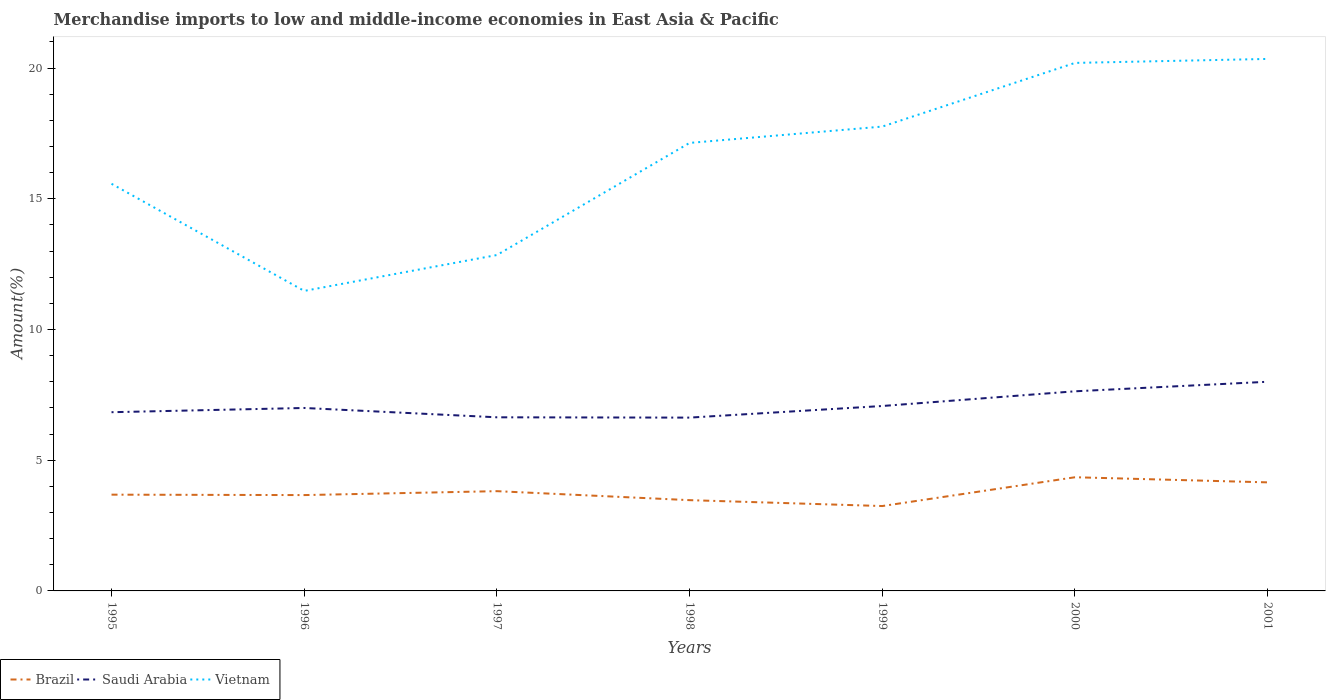How many different coloured lines are there?
Provide a short and direct response. 3. Does the line corresponding to Saudi Arabia intersect with the line corresponding to Vietnam?
Your answer should be compact. No. Across all years, what is the maximum percentage of amount earned from merchandise imports in Brazil?
Provide a succinct answer. 3.25. In which year was the percentage of amount earned from merchandise imports in Vietnam maximum?
Your answer should be very brief. 1996. What is the total percentage of amount earned from merchandise imports in Brazil in the graph?
Your answer should be compact. 0.44. What is the difference between the highest and the second highest percentage of amount earned from merchandise imports in Saudi Arabia?
Give a very brief answer. 1.37. What is the difference between the highest and the lowest percentage of amount earned from merchandise imports in Vietnam?
Provide a short and direct response. 4. How many years are there in the graph?
Keep it short and to the point. 7. What is the difference between two consecutive major ticks on the Y-axis?
Ensure brevity in your answer.  5. Does the graph contain any zero values?
Your answer should be compact. No. Does the graph contain grids?
Provide a succinct answer. No. Where does the legend appear in the graph?
Offer a terse response. Bottom left. What is the title of the graph?
Your answer should be compact. Merchandise imports to low and middle-income economies in East Asia & Pacific. Does "Tuvalu" appear as one of the legend labels in the graph?
Offer a very short reply. No. What is the label or title of the X-axis?
Provide a succinct answer. Years. What is the label or title of the Y-axis?
Offer a very short reply. Amount(%). What is the Amount(%) of Brazil in 1995?
Your answer should be compact. 3.68. What is the Amount(%) in Saudi Arabia in 1995?
Ensure brevity in your answer.  6.84. What is the Amount(%) of Vietnam in 1995?
Provide a succinct answer. 15.57. What is the Amount(%) in Brazil in 1996?
Ensure brevity in your answer.  3.67. What is the Amount(%) in Saudi Arabia in 1996?
Provide a succinct answer. 7. What is the Amount(%) in Vietnam in 1996?
Keep it short and to the point. 11.48. What is the Amount(%) of Brazil in 1997?
Make the answer very short. 3.82. What is the Amount(%) in Saudi Arabia in 1997?
Your response must be concise. 6.64. What is the Amount(%) in Vietnam in 1997?
Your answer should be compact. 12.85. What is the Amount(%) of Brazil in 1998?
Offer a terse response. 3.47. What is the Amount(%) in Saudi Arabia in 1998?
Offer a terse response. 6.63. What is the Amount(%) of Vietnam in 1998?
Keep it short and to the point. 17.14. What is the Amount(%) of Brazil in 1999?
Your answer should be compact. 3.25. What is the Amount(%) of Saudi Arabia in 1999?
Provide a short and direct response. 7.07. What is the Amount(%) in Vietnam in 1999?
Give a very brief answer. 17.76. What is the Amount(%) of Brazil in 2000?
Your answer should be compact. 4.35. What is the Amount(%) of Saudi Arabia in 2000?
Offer a terse response. 7.64. What is the Amount(%) of Vietnam in 2000?
Offer a very short reply. 20.2. What is the Amount(%) in Brazil in 2001?
Keep it short and to the point. 4.15. What is the Amount(%) in Saudi Arabia in 2001?
Your answer should be very brief. 8. What is the Amount(%) of Vietnam in 2001?
Provide a short and direct response. 20.35. Across all years, what is the maximum Amount(%) in Brazil?
Your answer should be very brief. 4.35. Across all years, what is the maximum Amount(%) of Saudi Arabia?
Offer a very short reply. 8. Across all years, what is the maximum Amount(%) of Vietnam?
Your answer should be very brief. 20.35. Across all years, what is the minimum Amount(%) of Brazil?
Provide a short and direct response. 3.25. Across all years, what is the minimum Amount(%) of Saudi Arabia?
Your response must be concise. 6.63. Across all years, what is the minimum Amount(%) in Vietnam?
Offer a very short reply. 11.48. What is the total Amount(%) in Brazil in the graph?
Your answer should be compact. 26.38. What is the total Amount(%) of Saudi Arabia in the graph?
Your answer should be very brief. 49.81. What is the total Amount(%) in Vietnam in the graph?
Keep it short and to the point. 115.34. What is the difference between the Amount(%) of Brazil in 1995 and that in 1996?
Your answer should be compact. 0.02. What is the difference between the Amount(%) in Saudi Arabia in 1995 and that in 1996?
Offer a very short reply. -0.16. What is the difference between the Amount(%) in Vietnam in 1995 and that in 1996?
Ensure brevity in your answer.  4.1. What is the difference between the Amount(%) of Brazil in 1995 and that in 1997?
Your answer should be compact. -0.13. What is the difference between the Amount(%) in Saudi Arabia in 1995 and that in 1997?
Your answer should be compact. 0.19. What is the difference between the Amount(%) of Vietnam in 1995 and that in 1997?
Offer a very short reply. 2.72. What is the difference between the Amount(%) of Brazil in 1995 and that in 1998?
Your response must be concise. 0.21. What is the difference between the Amount(%) in Saudi Arabia in 1995 and that in 1998?
Provide a succinct answer. 0.21. What is the difference between the Amount(%) of Vietnam in 1995 and that in 1998?
Keep it short and to the point. -1.56. What is the difference between the Amount(%) of Brazil in 1995 and that in 1999?
Your answer should be compact. 0.44. What is the difference between the Amount(%) of Saudi Arabia in 1995 and that in 1999?
Provide a short and direct response. -0.24. What is the difference between the Amount(%) in Vietnam in 1995 and that in 1999?
Your answer should be compact. -2.19. What is the difference between the Amount(%) in Brazil in 1995 and that in 2000?
Make the answer very short. -0.67. What is the difference between the Amount(%) of Saudi Arabia in 1995 and that in 2000?
Your answer should be compact. -0.8. What is the difference between the Amount(%) of Vietnam in 1995 and that in 2000?
Keep it short and to the point. -4.62. What is the difference between the Amount(%) of Brazil in 1995 and that in 2001?
Your answer should be very brief. -0.47. What is the difference between the Amount(%) in Saudi Arabia in 1995 and that in 2001?
Offer a terse response. -1.16. What is the difference between the Amount(%) in Vietnam in 1995 and that in 2001?
Your answer should be very brief. -4.78. What is the difference between the Amount(%) of Brazil in 1996 and that in 1997?
Your response must be concise. -0.15. What is the difference between the Amount(%) in Saudi Arabia in 1996 and that in 1997?
Provide a short and direct response. 0.36. What is the difference between the Amount(%) in Vietnam in 1996 and that in 1997?
Ensure brevity in your answer.  -1.37. What is the difference between the Amount(%) of Brazil in 1996 and that in 1998?
Ensure brevity in your answer.  0.19. What is the difference between the Amount(%) in Saudi Arabia in 1996 and that in 1998?
Offer a very short reply. 0.37. What is the difference between the Amount(%) of Vietnam in 1996 and that in 1998?
Make the answer very short. -5.66. What is the difference between the Amount(%) of Brazil in 1996 and that in 1999?
Offer a terse response. 0.42. What is the difference between the Amount(%) in Saudi Arabia in 1996 and that in 1999?
Offer a very short reply. -0.08. What is the difference between the Amount(%) of Vietnam in 1996 and that in 1999?
Your response must be concise. -6.29. What is the difference between the Amount(%) in Brazil in 1996 and that in 2000?
Make the answer very short. -0.68. What is the difference between the Amount(%) in Saudi Arabia in 1996 and that in 2000?
Ensure brevity in your answer.  -0.64. What is the difference between the Amount(%) in Vietnam in 1996 and that in 2000?
Your answer should be compact. -8.72. What is the difference between the Amount(%) in Brazil in 1996 and that in 2001?
Offer a terse response. -0.49. What is the difference between the Amount(%) in Saudi Arabia in 1996 and that in 2001?
Make the answer very short. -1. What is the difference between the Amount(%) of Vietnam in 1996 and that in 2001?
Offer a very short reply. -8.87. What is the difference between the Amount(%) of Brazil in 1997 and that in 1998?
Your response must be concise. 0.34. What is the difference between the Amount(%) in Saudi Arabia in 1997 and that in 1998?
Provide a short and direct response. 0.01. What is the difference between the Amount(%) in Vietnam in 1997 and that in 1998?
Give a very brief answer. -4.29. What is the difference between the Amount(%) of Brazil in 1997 and that in 1999?
Keep it short and to the point. 0.57. What is the difference between the Amount(%) in Saudi Arabia in 1997 and that in 1999?
Offer a very short reply. -0.43. What is the difference between the Amount(%) in Vietnam in 1997 and that in 1999?
Your answer should be very brief. -4.91. What is the difference between the Amount(%) in Brazil in 1997 and that in 2000?
Offer a very short reply. -0.53. What is the difference between the Amount(%) of Saudi Arabia in 1997 and that in 2000?
Provide a succinct answer. -0.99. What is the difference between the Amount(%) of Vietnam in 1997 and that in 2000?
Make the answer very short. -7.35. What is the difference between the Amount(%) in Brazil in 1997 and that in 2001?
Ensure brevity in your answer.  -0.34. What is the difference between the Amount(%) of Saudi Arabia in 1997 and that in 2001?
Make the answer very short. -1.36. What is the difference between the Amount(%) of Vietnam in 1997 and that in 2001?
Offer a very short reply. -7.5. What is the difference between the Amount(%) of Brazil in 1998 and that in 1999?
Your response must be concise. 0.23. What is the difference between the Amount(%) of Saudi Arabia in 1998 and that in 1999?
Your answer should be compact. -0.44. What is the difference between the Amount(%) of Vietnam in 1998 and that in 1999?
Make the answer very short. -0.62. What is the difference between the Amount(%) of Brazil in 1998 and that in 2000?
Make the answer very short. -0.88. What is the difference between the Amount(%) of Saudi Arabia in 1998 and that in 2000?
Provide a succinct answer. -1.01. What is the difference between the Amount(%) of Vietnam in 1998 and that in 2000?
Ensure brevity in your answer.  -3.06. What is the difference between the Amount(%) of Brazil in 1998 and that in 2001?
Make the answer very short. -0.68. What is the difference between the Amount(%) of Saudi Arabia in 1998 and that in 2001?
Offer a terse response. -1.37. What is the difference between the Amount(%) in Vietnam in 1998 and that in 2001?
Your answer should be compact. -3.21. What is the difference between the Amount(%) of Brazil in 1999 and that in 2000?
Ensure brevity in your answer.  -1.1. What is the difference between the Amount(%) of Saudi Arabia in 1999 and that in 2000?
Your answer should be compact. -0.56. What is the difference between the Amount(%) in Vietnam in 1999 and that in 2000?
Your response must be concise. -2.44. What is the difference between the Amount(%) of Brazil in 1999 and that in 2001?
Keep it short and to the point. -0.91. What is the difference between the Amount(%) of Saudi Arabia in 1999 and that in 2001?
Your response must be concise. -0.93. What is the difference between the Amount(%) in Vietnam in 1999 and that in 2001?
Offer a terse response. -2.59. What is the difference between the Amount(%) in Brazil in 2000 and that in 2001?
Keep it short and to the point. 0.2. What is the difference between the Amount(%) in Saudi Arabia in 2000 and that in 2001?
Keep it short and to the point. -0.36. What is the difference between the Amount(%) in Vietnam in 2000 and that in 2001?
Ensure brevity in your answer.  -0.15. What is the difference between the Amount(%) of Brazil in 1995 and the Amount(%) of Saudi Arabia in 1996?
Your answer should be very brief. -3.32. What is the difference between the Amount(%) of Brazil in 1995 and the Amount(%) of Vietnam in 1996?
Provide a short and direct response. -7.79. What is the difference between the Amount(%) of Saudi Arabia in 1995 and the Amount(%) of Vietnam in 1996?
Make the answer very short. -4.64. What is the difference between the Amount(%) of Brazil in 1995 and the Amount(%) of Saudi Arabia in 1997?
Make the answer very short. -2.96. What is the difference between the Amount(%) in Brazil in 1995 and the Amount(%) in Vietnam in 1997?
Keep it short and to the point. -9.17. What is the difference between the Amount(%) in Saudi Arabia in 1995 and the Amount(%) in Vietnam in 1997?
Offer a terse response. -6.01. What is the difference between the Amount(%) in Brazil in 1995 and the Amount(%) in Saudi Arabia in 1998?
Keep it short and to the point. -2.95. What is the difference between the Amount(%) of Brazil in 1995 and the Amount(%) of Vietnam in 1998?
Make the answer very short. -13.45. What is the difference between the Amount(%) of Saudi Arabia in 1995 and the Amount(%) of Vietnam in 1998?
Your answer should be very brief. -10.3. What is the difference between the Amount(%) of Brazil in 1995 and the Amount(%) of Saudi Arabia in 1999?
Ensure brevity in your answer.  -3.39. What is the difference between the Amount(%) of Brazil in 1995 and the Amount(%) of Vietnam in 1999?
Make the answer very short. -14.08. What is the difference between the Amount(%) of Saudi Arabia in 1995 and the Amount(%) of Vietnam in 1999?
Keep it short and to the point. -10.93. What is the difference between the Amount(%) in Brazil in 1995 and the Amount(%) in Saudi Arabia in 2000?
Offer a terse response. -3.95. What is the difference between the Amount(%) in Brazil in 1995 and the Amount(%) in Vietnam in 2000?
Your answer should be compact. -16.51. What is the difference between the Amount(%) in Saudi Arabia in 1995 and the Amount(%) in Vietnam in 2000?
Your response must be concise. -13.36. What is the difference between the Amount(%) of Brazil in 1995 and the Amount(%) of Saudi Arabia in 2001?
Offer a terse response. -4.32. What is the difference between the Amount(%) of Brazil in 1995 and the Amount(%) of Vietnam in 2001?
Offer a terse response. -16.67. What is the difference between the Amount(%) in Saudi Arabia in 1995 and the Amount(%) in Vietnam in 2001?
Offer a terse response. -13.51. What is the difference between the Amount(%) of Brazil in 1996 and the Amount(%) of Saudi Arabia in 1997?
Your response must be concise. -2.98. What is the difference between the Amount(%) of Brazil in 1996 and the Amount(%) of Vietnam in 1997?
Your answer should be very brief. -9.18. What is the difference between the Amount(%) in Saudi Arabia in 1996 and the Amount(%) in Vietnam in 1997?
Your response must be concise. -5.85. What is the difference between the Amount(%) of Brazil in 1996 and the Amount(%) of Saudi Arabia in 1998?
Offer a very short reply. -2.96. What is the difference between the Amount(%) of Brazil in 1996 and the Amount(%) of Vietnam in 1998?
Provide a short and direct response. -13.47. What is the difference between the Amount(%) of Saudi Arabia in 1996 and the Amount(%) of Vietnam in 1998?
Provide a succinct answer. -10.14. What is the difference between the Amount(%) of Brazil in 1996 and the Amount(%) of Saudi Arabia in 1999?
Make the answer very short. -3.41. What is the difference between the Amount(%) of Brazil in 1996 and the Amount(%) of Vietnam in 1999?
Give a very brief answer. -14.1. What is the difference between the Amount(%) in Saudi Arabia in 1996 and the Amount(%) in Vietnam in 1999?
Provide a short and direct response. -10.76. What is the difference between the Amount(%) in Brazil in 1996 and the Amount(%) in Saudi Arabia in 2000?
Offer a very short reply. -3.97. What is the difference between the Amount(%) in Brazil in 1996 and the Amount(%) in Vietnam in 2000?
Ensure brevity in your answer.  -16.53. What is the difference between the Amount(%) in Saudi Arabia in 1996 and the Amount(%) in Vietnam in 2000?
Ensure brevity in your answer.  -13.2. What is the difference between the Amount(%) in Brazil in 1996 and the Amount(%) in Saudi Arabia in 2001?
Your answer should be very brief. -4.33. What is the difference between the Amount(%) of Brazil in 1996 and the Amount(%) of Vietnam in 2001?
Provide a succinct answer. -16.68. What is the difference between the Amount(%) in Saudi Arabia in 1996 and the Amount(%) in Vietnam in 2001?
Provide a succinct answer. -13.35. What is the difference between the Amount(%) in Brazil in 1997 and the Amount(%) in Saudi Arabia in 1998?
Provide a short and direct response. -2.81. What is the difference between the Amount(%) of Brazil in 1997 and the Amount(%) of Vietnam in 1998?
Provide a succinct answer. -13.32. What is the difference between the Amount(%) of Saudi Arabia in 1997 and the Amount(%) of Vietnam in 1998?
Keep it short and to the point. -10.5. What is the difference between the Amount(%) in Brazil in 1997 and the Amount(%) in Saudi Arabia in 1999?
Your answer should be compact. -3.26. What is the difference between the Amount(%) of Brazil in 1997 and the Amount(%) of Vietnam in 1999?
Provide a short and direct response. -13.95. What is the difference between the Amount(%) in Saudi Arabia in 1997 and the Amount(%) in Vietnam in 1999?
Keep it short and to the point. -11.12. What is the difference between the Amount(%) in Brazil in 1997 and the Amount(%) in Saudi Arabia in 2000?
Your response must be concise. -3.82. What is the difference between the Amount(%) in Brazil in 1997 and the Amount(%) in Vietnam in 2000?
Offer a very short reply. -16.38. What is the difference between the Amount(%) of Saudi Arabia in 1997 and the Amount(%) of Vietnam in 2000?
Offer a very short reply. -13.56. What is the difference between the Amount(%) in Brazil in 1997 and the Amount(%) in Saudi Arabia in 2001?
Your answer should be very brief. -4.18. What is the difference between the Amount(%) of Brazil in 1997 and the Amount(%) of Vietnam in 2001?
Your answer should be very brief. -16.53. What is the difference between the Amount(%) of Saudi Arabia in 1997 and the Amount(%) of Vietnam in 2001?
Make the answer very short. -13.71. What is the difference between the Amount(%) in Brazil in 1998 and the Amount(%) in Saudi Arabia in 1999?
Ensure brevity in your answer.  -3.6. What is the difference between the Amount(%) in Brazil in 1998 and the Amount(%) in Vietnam in 1999?
Give a very brief answer. -14.29. What is the difference between the Amount(%) of Saudi Arabia in 1998 and the Amount(%) of Vietnam in 1999?
Provide a short and direct response. -11.13. What is the difference between the Amount(%) of Brazil in 1998 and the Amount(%) of Saudi Arabia in 2000?
Keep it short and to the point. -4.16. What is the difference between the Amount(%) of Brazil in 1998 and the Amount(%) of Vietnam in 2000?
Offer a very short reply. -16.72. What is the difference between the Amount(%) in Saudi Arabia in 1998 and the Amount(%) in Vietnam in 2000?
Your answer should be compact. -13.57. What is the difference between the Amount(%) in Brazil in 1998 and the Amount(%) in Saudi Arabia in 2001?
Your answer should be very brief. -4.53. What is the difference between the Amount(%) of Brazil in 1998 and the Amount(%) of Vietnam in 2001?
Your response must be concise. -16.88. What is the difference between the Amount(%) of Saudi Arabia in 1998 and the Amount(%) of Vietnam in 2001?
Your answer should be very brief. -13.72. What is the difference between the Amount(%) in Brazil in 1999 and the Amount(%) in Saudi Arabia in 2000?
Ensure brevity in your answer.  -4.39. What is the difference between the Amount(%) of Brazil in 1999 and the Amount(%) of Vietnam in 2000?
Offer a very short reply. -16.95. What is the difference between the Amount(%) of Saudi Arabia in 1999 and the Amount(%) of Vietnam in 2000?
Make the answer very short. -13.12. What is the difference between the Amount(%) in Brazil in 1999 and the Amount(%) in Saudi Arabia in 2001?
Your answer should be compact. -4.75. What is the difference between the Amount(%) of Brazil in 1999 and the Amount(%) of Vietnam in 2001?
Your answer should be very brief. -17.1. What is the difference between the Amount(%) in Saudi Arabia in 1999 and the Amount(%) in Vietnam in 2001?
Keep it short and to the point. -13.28. What is the difference between the Amount(%) in Brazil in 2000 and the Amount(%) in Saudi Arabia in 2001?
Ensure brevity in your answer.  -3.65. What is the difference between the Amount(%) in Brazil in 2000 and the Amount(%) in Vietnam in 2001?
Provide a succinct answer. -16. What is the difference between the Amount(%) in Saudi Arabia in 2000 and the Amount(%) in Vietnam in 2001?
Provide a succinct answer. -12.71. What is the average Amount(%) of Brazil per year?
Make the answer very short. 3.77. What is the average Amount(%) in Saudi Arabia per year?
Provide a short and direct response. 7.12. What is the average Amount(%) of Vietnam per year?
Offer a very short reply. 16.48. In the year 1995, what is the difference between the Amount(%) in Brazil and Amount(%) in Saudi Arabia?
Provide a short and direct response. -3.15. In the year 1995, what is the difference between the Amount(%) in Brazil and Amount(%) in Vietnam?
Your response must be concise. -11.89. In the year 1995, what is the difference between the Amount(%) in Saudi Arabia and Amount(%) in Vietnam?
Your answer should be very brief. -8.74. In the year 1996, what is the difference between the Amount(%) of Brazil and Amount(%) of Saudi Arabia?
Offer a terse response. -3.33. In the year 1996, what is the difference between the Amount(%) of Brazil and Amount(%) of Vietnam?
Offer a very short reply. -7.81. In the year 1996, what is the difference between the Amount(%) in Saudi Arabia and Amount(%) in Vietnam?
Offer a very short reply. -4.48. In the year 1997, what is the difference between the Amount(%) of Brazil and Amount(%) of Saudi Arabia?
Ensure brevity in your answer.  -2.83. In the year 1997, what is the difference between the Amount(%) of Brazil and Amount(%) of Vietnam?
Offer a very short reply. -9.03. In the year 1997, what is the difference between the Amount(%) in Saudi Arabia and Amount(%) in Vietnam?
Give a very brief answer. -6.21. In the year 1998, what is the difference between the Amount(%) of Brazil and Amount(%) of Saudi Arabia?
Provide a short and direct response. -3.16. In the year 1998, what is the difference between the Amount(%) of Brazil and Amount(%) of Vietnam?
Your answer should be compact. -13.66. In the year 1998, what is the difference between the Amount(%) of Saudi Arabia and Amount(%) of Vietnam?
Provide a succinct answer. -10.51. In the year 1999, what is the difference between the Amount(%) in Brazil and Amount(%) in Saudi Arabia?
Your response must be concise. -3.83. In the year 1999, what is the difference between the Amount(%) of Brazil and Amount(%) of Vietnam?
Ensure brevity in your answer.  -14.51. In the year 1999, what is the difference between the Amount(%) in Saudi Arabia and Amount(%) in Vietnam?
Your answer should be very brief. -10.69. In the year 2000, what is the difference between the Amount(%) in Brazil and Amount(%) in Saudi Arabia?
Provide a succinct answer. -3.29. In the year 2000, what is the difference between the Amount(%) of Brazil and Amount(%) of Vietnam?
Your answer should be compact. -15.85. In the year 2000, what is the difference between the Amount(%) of Saudi Arabia and Amount(%) of Vietnam?
Provide a succinct answer. -12.56. In the year 2001, what is the difference between the Amount(%) of Brazil and Amount(%) of Saudi Arabia?
Make the answer very short. -3.85. In the year 2001, what is the difference between the Amount(%) in Brazil and Amount(%) in Vietnam?
Provide a short and direct response. -16.2. In the year 2001, what is the difference between the Amount(%) in Saudi Arabia and Amount(%) in Vietnam?
Ensure brevity in your answer.  -12.35. What is the ratio of the Amount(%) in Saudi Arabia in 1995 to that in 1996?
Offer a very short reply. 0.98. What is the ratio of the Amount(%) of Vietnam in 1995 to that in 1996?
Make the answer very short. 1.36. What is the ratio of the Amount(%) of Saudi Arabia in 1995 to that in 1997?
Provide a short and direct response. 1.03. What is the ratio of the Amount(%) in Vietnam in 1995 to that in 1997?
Provide a short and direct response. 1.21. What is the ratio of the Amount(%) of Brazil in 1995 to that in 1998?
Your answer should be compact. 1.06. What is the ratio of the Amount(%) of Saudi Arabia in 1995 to that in 1998?
Offer a very short reply. 1.03. What is the ratio of the Amount(%) in Vietnam in 1995 to that in 1998?
Your answer should be very brief. 0.91. What is the ratio of the Amount(%) in Brazil in 1995 to that in 1999?
Provide a succinct answer. 1.13. What is the ratio of the Amount(%) of Saudi Arabia in 1995 to that in 1999?
Offer a very short reply. 0.97. What is the ratio of the Amount(%) in Vietnam in 1995 to that in 1999?
Your response must be concise. 0.88. What is the ratio of the Amount(%) of Brazil in 1995 to that in 2000?
Give a very brief answer. 0.85. What is the ratio of the Amount(%) in Saudi Arabia in 1995 to that in 2000?
Provide a short and direct response. 0.9. What is the ratio of the Amount(%) of Vietnam in 1995 to that in 2000?
Your answer should be very brief. 0.77. What is the ratio of the Amount(%) in Brazil in 1995 to that in 2001?
Your answer should be very brief. 0.89. What is the ratio of the Amount(%) in Saudi Arabia in 1995 to that in 2001?
Keep it short and to the point. 0.85. What is the ratio of the Amount(%) in Vietnam in 1995 to that in 2001?
Your answer should be compact. 0.77. What is the ratio of the Amount(%) in Brazil in 1996 to that in 1997?
Your response must be concise. 0.96. What is the ratio of the Amount(%) of Saudi Arabia in 1996 to that in 1997?
Give a very brief answer. 1.05. What is the ratio of the Amount(%) of Vietnam in 1996 to that in 1997?
Keep it short and to the point. 0.89. What is the ratio of the Amount(%) in Brazil in 1996 to that in 1998?
Provide a short and direct response. 1.06. What is the ratio of the Amount(%) in Saudi Arabia in 1996 to that in 1998?
Offer a terse response. 1.06. What is the ratio of the Amount(%) of Vietnam in 1996 to that in 1998?
Provide a short and direct response. 0.67. What is the ratio of the Amount(%) in Brazil in 1996 to that in 1999?
Your answer should be very brief. 1.13. What is the ratio of the Amount(%) in Saudi Arabia in 1996 to that in 1999?
Provide a short and direct response. 0.99. What is the ratio of the Amount(%) of Vietnam in 1996 to that in 1999?
Offer a very short reply. 0.65. What is the ratio of the Amount(%) of Brazil in 1996 to that in 2000?
Provide a short and direct response. 0.84. What is the ratio of the Amount(%) of Saudi Arabia in 1996 to that in 2000?
Offer a terse response. 0.92. What is the ratio of the Amount(%) of Vietnam in 1996 to that in 2000?
Provide a short and direct response. 0.57. What is the ratio of the Amount(%) in Brazil in 1996 to that in 2001?
Your response must be concise. 0.88. What is the ratio of the Amount(%) of Saudi Arabia in 1996 to that in 2001?
Provide a short and direct response. 0.87. What is the ratio of the Amount(%) of Vietnam in 1996 to that in 2001?
Offer a terse response. 0.56. What is the ratio of the Amount(%) of Brazil in 1997 to that in 1998?
Provide a short and direct response. 1.1. What is the ratio of the Amount(%) of Saudi Arabia in 1997 to that in 1998?
Offer a terse response. 1. What is the ratio of the Amount(%) of Vietnam in 1997 to that in 1998?
Keep it short and to the point. 0.75. What is the ratio of the Amount(%) in Brazil in 1997 to that in 1999?
Give a very brief answer. 1.18. What is the ratio of the Amount(%) of Saudi Arabia in 1997 to that in 1999?
Ensure brevity in your answer.  0.94. What is the ratio of the Amount(%) of Vietnam in 1997 to that in 1999?
Give a very brief answer. 0.72. What is the ratio of the Amount(%) of Brazil in 1997 to that in 2000?
Give a very brief answer. 0.88. What is the ratio of the Amount(%) of Saudi Arabia in 1997 to that in 2000?
Offer a terse response. 0.87. What is the ratio of the Amount(%) of Vietnam in 1997 to that in 2000?
Offer a terse response. 0.64. What is the ratio of the Amount(%) of Brazil in 1997 to that in 2001?
Offer a very short reply. 0.92. What is the ratio of the Amount(%) in Saudi Arabia in 1997 to that in 2001?
Your response must be concise. 0.83. What is the ratio of the Amount(%) in Vietnam in 1997 to that in 2001?
Ensure brevity in your answer.  0.63. What is the ratio of the Amount(%) in Brazil in 1998 to that in 1999?
Offer a very short reply. 1.07. What is the ratio of the Amount(%) in Saudi Arabia in 1998 to that in 1999?
Your response must be concise. 0.94. What is the ratio of the Amount(%) of Vietnam in 1998 to that in 1999?
Make the answer very short. 0.96. What is the ratio of the Amount(%) of Brazil in 1998 to that in 2000?
Offer a terse response. 0.8. What is the ratio of the Amount(%) in Saudi Arabia in 1998 to that in 2000?
Your answer should be compact. 0.87. What is the ratio of the Amount(%) in Vietnam in 1998 to that in 2000?
Ensure brevity in your answer.  0.85. What is the ratio of the Amount(%) in Brazil in 1998 to that in 2001?
Offer a very short reply. 0.84. What is the ratio of the Amount(%) in Saudi Arabia in 1998 to that in 2001?
Offer a terse response. 0.83. What is the ratio of the Amount(%) in Vietnam in 1998 to that in 2001?
Offer a very short reply. 0.84. What is the ratio of the Amount(%) in Brazil in 1999 to that in 2000?
Provide a short and direct response. 0.75. What is the ratio of the Amount(%) in Saudi Arabia in 1999 to that in 2000?
Your response must be concise. 0.93. What is the ratio of the Amount(%) of Vietnam in 1999 to that in 2000?
Offer a very short reply. 0.88. What is the ratio of the Amount(%) in Brazil in 1999 to that in 2001?
Offer a very short reply. 0.78. What is the ratio of the Amount(%) in Saudi Arabia in 1999 to that in 2001?
Your answer should be compact. 0.88. What is the ratio of the Amount(%) in Vietnam in 1999 to that in 2001?
Provide a succinct answer. 0.87. What is the ratio of the Amount(%) of Brazil in 2000 to that in 2001?
Offer a terse response. 1.05. What is the ratio of the Amount(%) in Saudi Arabia in 2000 to that in 2001?
Offer a very short reply. 0.95. What is the ratio of the Amount(%) of Vietnam in 2000 to that in 2001?
Offer a terse response. 0.99. What is the difference between the highest and the second highest Amount(%) of Brazil?
Make the answer very short. 0.2. What is the difference between the highest and the second highest Amount(%) of Saudi Arabia?
Give a very brief answer. 0.36. What is the difference between the highest and the second highest Amount(%) in Vietnam?
Make the answer very short. 0.15. What is the difference between the highest and the lowest Amount(%) in Brazil?
Provide a succinct answer. 1.1. What is the difference between the highest and the lowest Amount(%) of Saudi Arabia?
Offer a terse response. 1.37. What is the difference between the highest and the lowest Amount(%) of Vietnam?
Ensure brevity in your answer.  8.87. 